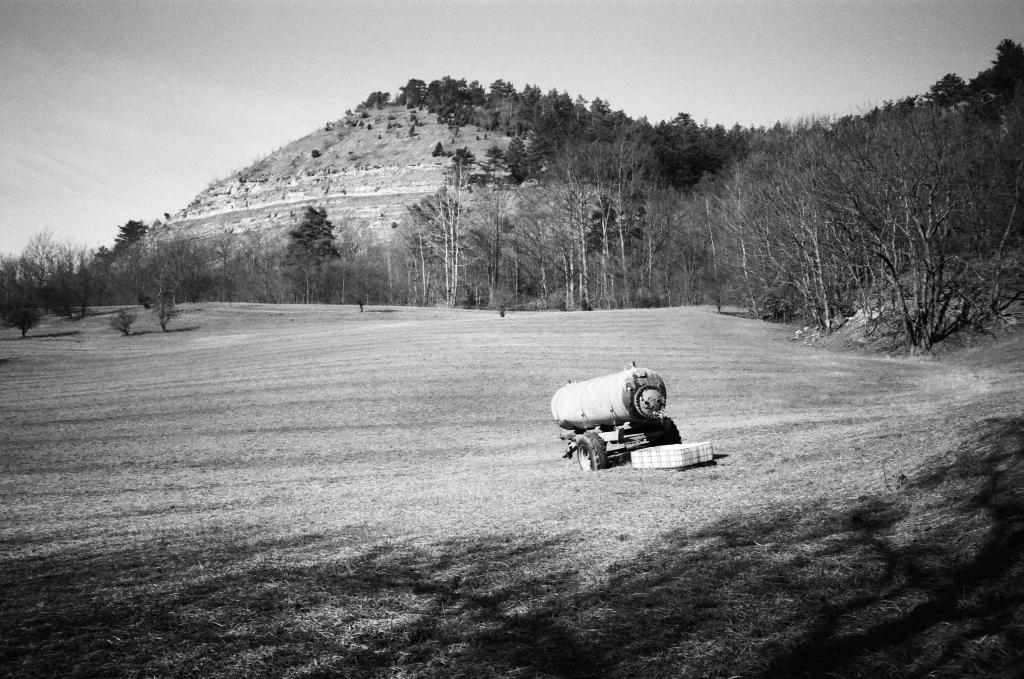What type of ground surface is visible in the image? There is grass on the ground in the image. What structure can be seen in the image? There is a water tank in the image. What type of vegetation is present in the image? There are trees in the image. What geographical feature is visible in the image? There is a mountain in the image. What is visible at the top of the image? The sky is visible at the top of the image. Can you see any guns in the image? There are no guns present in the image. What type of observation can be made from the top of the mountain in the image? There is no indication of anyone making an observation from the top of the mountain in the image. 